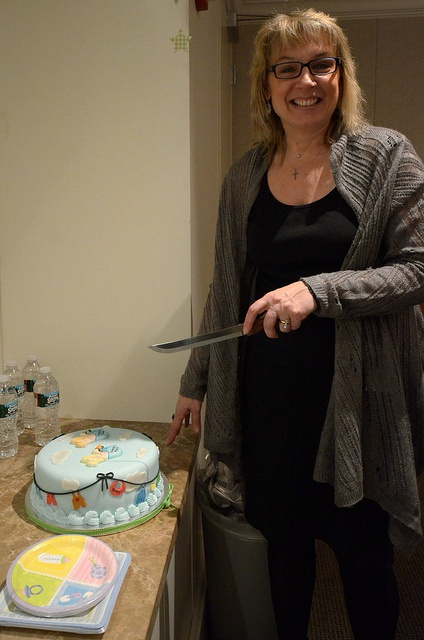Describe the objects in this image and their specific colors. I can see people in gray, black, and maroon tones, dining table in gray, black, tan, maroon, and olive tones, cake in gray, darkgray, beige, and tan tones, bottle in gray and darkgray tones, and knife in gray and black tones in this image. 